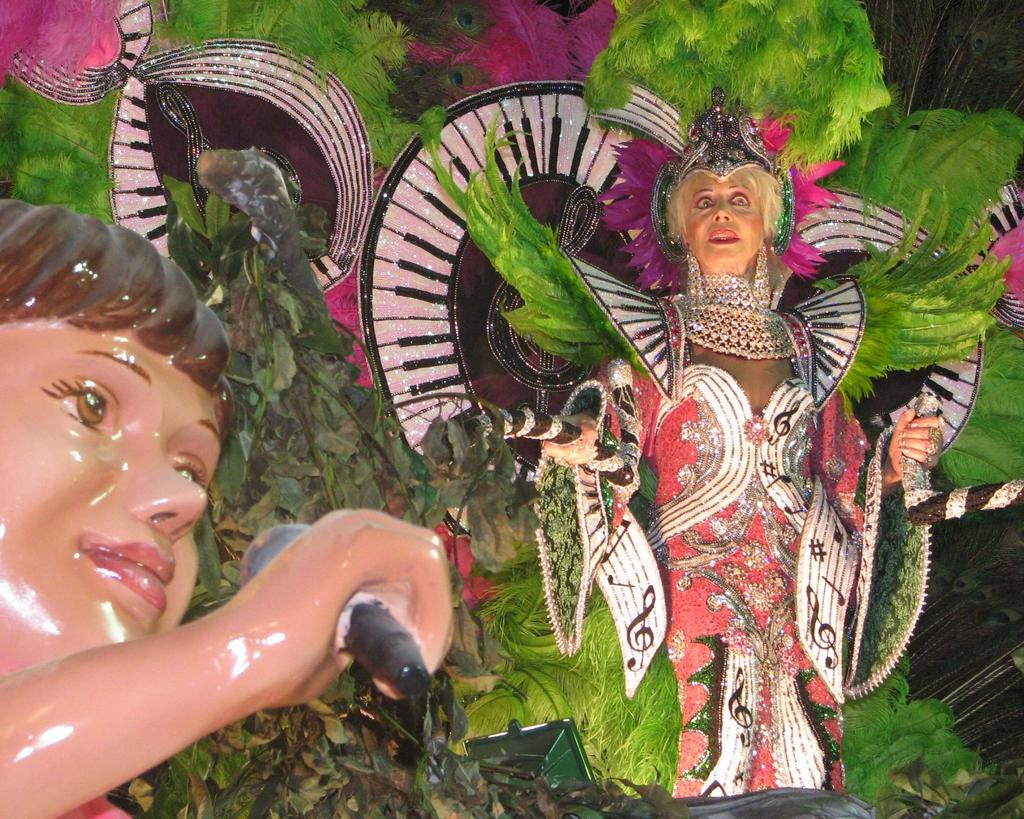What type of living organism can be seen in the image? There is a plant in the image. What other objects are present in the image besides the plant? There are statues in the image. What type of fabric is used to make the can in the image? There is no can present in the image, so it is not possible to determine the type of fabric used. 